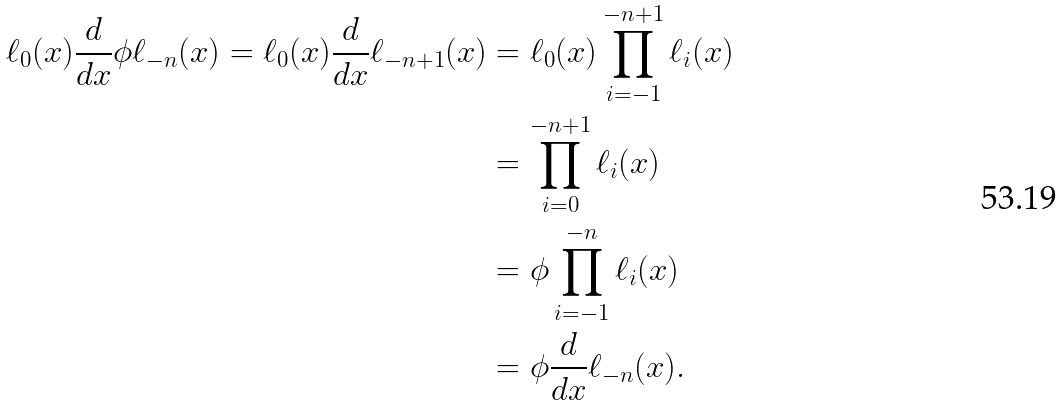Convert formula to latex. <formula><loc_0><loc_0><loc_500><loc_500>\ell _ { 0 } ( x ) \frac { d } { d x } \phi \ell _ { - n } ( x ) = \ell _ { 0 } ( x ) \frac { d } { d x } \ell _ { - n + 1 } ( x ) & = \ell _ { 0 } ( x ) \prod _ { i = - 1 } ^ { - n + 1 } \ell _ { i } ( x ) \\ & = \prod _ { i = 0 } ^ { - n + 1 } \ell _ { i } ( x ) \\ & = \phi \prod _ { i = - 1 } ^ { - n } \ell _ { i } ( x ) \\ & = \phi \frac { d } { d x } \ell _ { - n } ( x ) .</formula> 